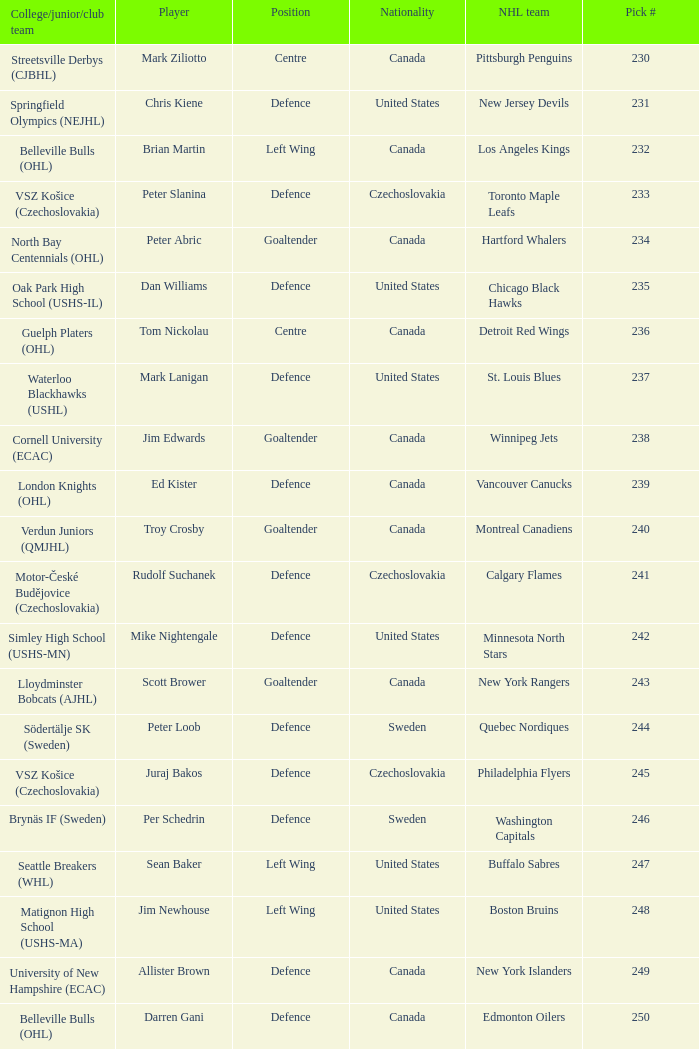Which draft number did the new jersey devils get? 231.0. 